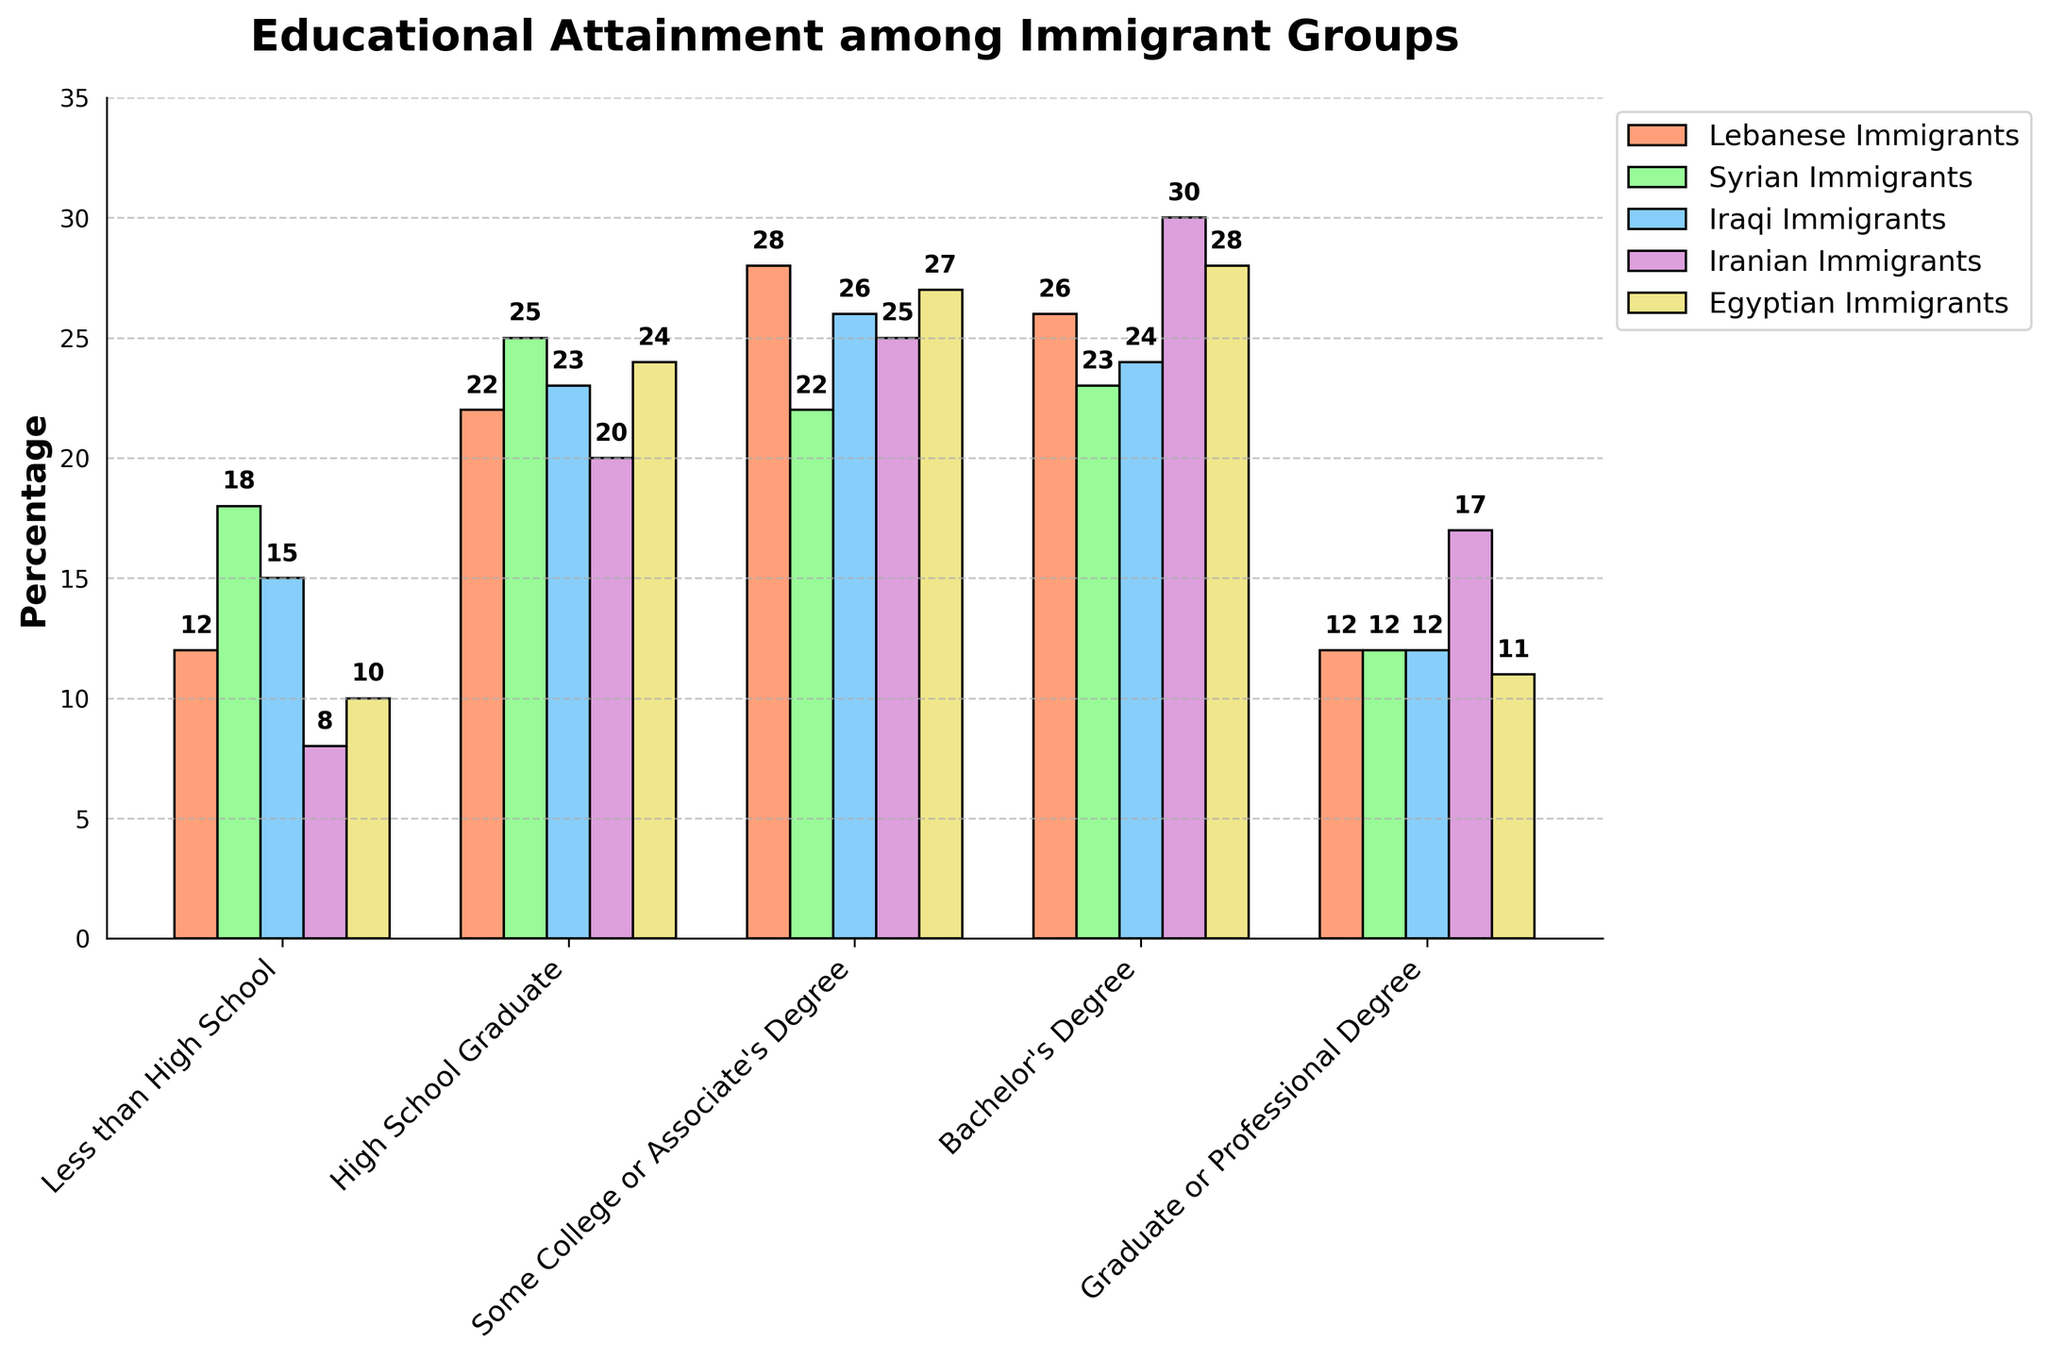Which immigrant group has the highest percentage of Bachelor's Degree holders? Look at the bar heights in the section labeled "Bachelor's Degree" for each group. The tallest bar is for the Iranian Immigrants group.
Answer: Iranian Immigrants What's the difference in the percentage of Lebanese Immigrants with less than High School education compared to Syrian Immigrants? Subtract the percentage of Lebanese Immigrants with less than High School education from the percentage for Syrian Immigrants: 18 - 12 = 6%.
Answer: 6% Which educational attainment category has the smallest percentage of Lebanese Immigrants? Look at the bar heights for Lebanese Immigrants in each educational category and identify the shortest bar, which is for "Less than High School".
Answer: Less than High School How does the percentage of Lebanese Immigrants with a Graduate or Professional Degree compare to that of Iranian Immigrants? Check the bar heights in "Graduate or Professional Degree" for both groups: Lebanese Immigrants (12%) and Iranian Immigrants (17%). Lebanese Immigrants have a lower percentage.
Answer: Lower What is the average percentage of Lebanese Immigrants across all educational attainment categories? Sum the percentages of Lebanese Immigrants in each category and divide by the number of categories: (12 + 22 + 28 + 26 + 12) / 5 = 20%.
Answer: 20% Which educational attainment category shows the closest percentages among all immigrant groups? Check the percentages for each category among all groups; "Graduate or Professional Degree" has the percentages: Lebanese (12), Syrian (12), Iraqi (12), Iranian (17), Egyptian (11), which are relatively close.
Answer: Graduate or Professional Degree By how much does the percentage of High School Graduates differ between the Egyptian Immigrants and the Lebanese Immigrants? Subtract the percentage of Lebanese Immigrants who are High School Graduates from the percentage for Egyptian Immigrants: 24 - 22 = 2%.
Answer: 2% Rank the immigrant groups from highest to lowest based on their percentage of individuals with a Bachelor's Degree. List the groups in descending order by their percentages for Bachelor's Degree: Iranian (30), Egyptian (28), Iraqi (24), Syrian (23), Lebanese (26).
Answer: Iranian, Egyptian, Lebanese, Iraqi, Syrian Which group has the least variation in percentages across all educational categories? Look at the data for all categories and compare the ranges. Lebanese Immigrants have percentages from 12% to 28%, showing less variation compared to others.
Answer: Lebanese Immigrants 